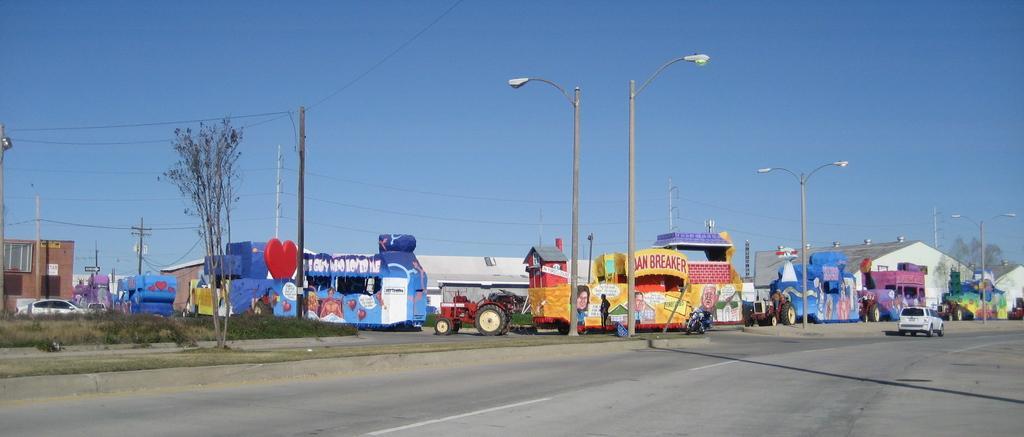In one or two sentences, can you explain what this image depicts? In this image there are vehicles on the road. There are street lights, trees, current polls. In the background of the image there are buildings and sky. 